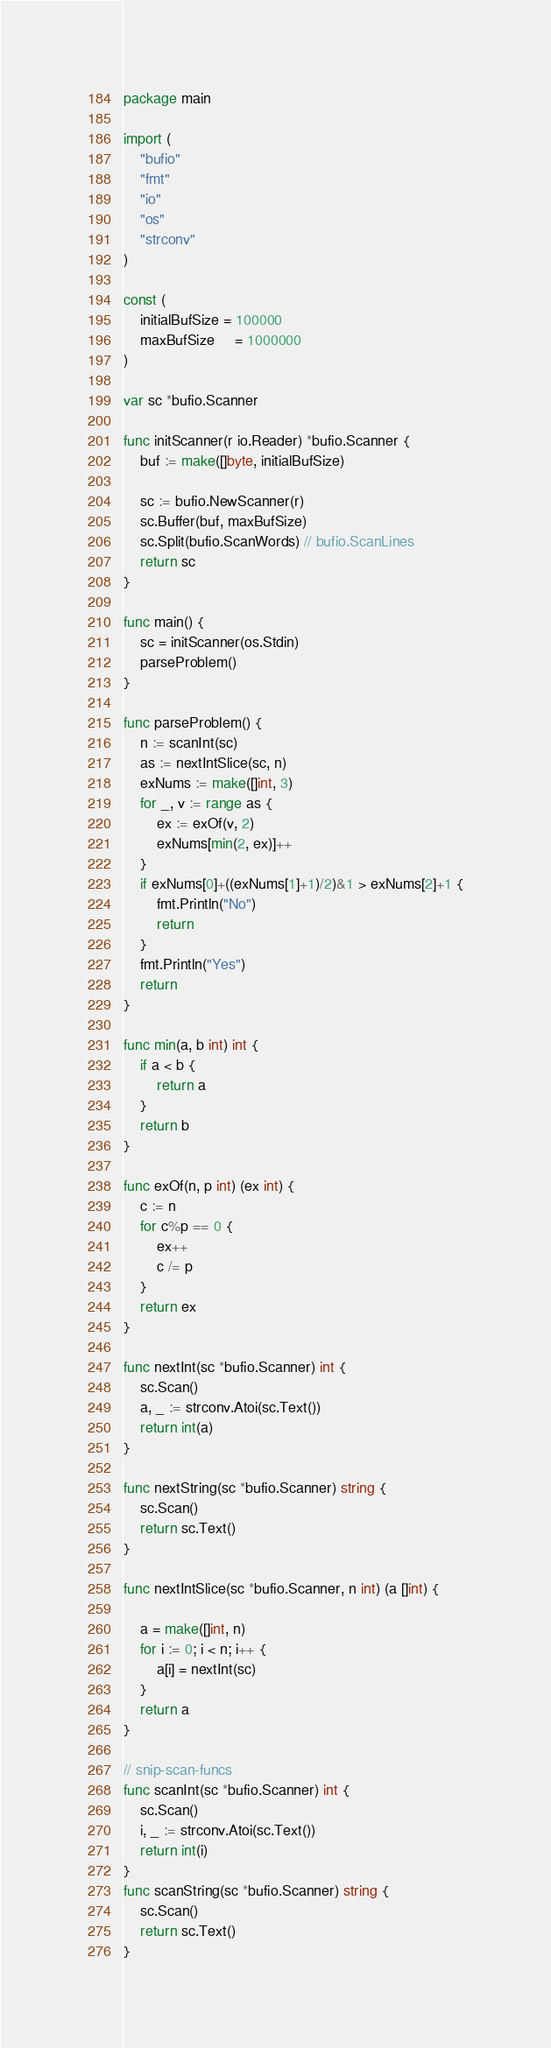Convert code to text. <code><loc_0><loc_0><loc_500><loc_500><_Go_>package main

import (
	"bufio"
	"fmt"
	"io"
	"os"
	"strconv"
)

const (
	initialBufSize = 100000
	maxBufSize     = 1000000
)

var sc *bufio.Scanner

func initScanner(r io.Reader) *bufio.Scanner {
	buf := make([]byte, initialBufSize)

	sc := bufio.NewScanner(r)
	sc.Buffer(buf, maxBufSize)
	sc.Split(bufio.ScanWords) // bufio.ScanLines
	return sc
}

func main() {
	sc = initScanner(os.Stdin)
	parseProblem()
}

func parseProblem() {
	n := scanInt(sc)
	as := nextIntSlice(sc, n)
	exNums := make([]int, 3)
	for _, v := range as {
		ex := exOf(v, 2)
		exNums[min(2, ex)]++
	}
	if exNums[0]+((exNums[1]+1)/2)&1 > exNums[2]+1 {
		fmt.Println("No")
		return
	}
	fmt.Println("Yes")
	return
}

func min(a, b int) int {
	if a < b {
		return a
	}
	return b
}

func exOf(n, p int) (ex int) {
	c := n
	for c%p == 0 {
		ex++
		c /= p
	}
	return ex
}

func nextInt(sc *bufio.Scanner) int {
	sc.Scan()
	a, _ := strconv.Atoi(sc.Text())
	return int(a)
}

func nextString(sc *bufio.Scanner) string {
	sc.Scan()
	return sc.Text()
}

func nextIntSlice(sc *bufio.Scanner, n int) (a []int) {

	a = make([]int, n)
	for i := 0; i < n; i++ {
		a[i] = nextInt(sc)
	}
	return a
}

// snip-scan-funcs
func scanInt(sc *bufio.Scanner) int {
	sc.Scan()
	i, _ := strconv.Atoi(sc.Text())
	return int(i)
}
func scanString(sc *bufio.Scanner) string {
	sc.Scan()
	return sc.Text()
}
</code> 